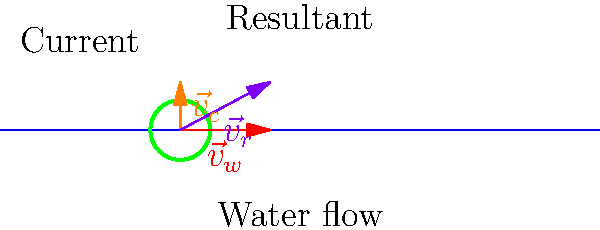A raft is floating down the Li River near Longyan Township. The water is flowing east at 3 m/s, and there's a current pushing the raft north at 1.6 m/s. What is the resultant velocity vector of the raft? To find the resultant velocity vector of the raft, we need to add the two given velocity vectors:

1) Water flow velocity (east): $\vec{v}_w = 3\hat{i}$ m/s
2) Current velocity (north): $\vec{v}_c = 1.6\hat{j}$ m/s

The resultant velocity $\vec{v}_r$ is the vector sum of these two velocities:

$$\vec{v}_r = \vec{v}_w + \vec{v}_c = 3\hat{i} + 1.6\hat{j}$$

To express this as a single vector:

1) The x-component (east) is 3 m/s
2) The y-component (north) is 1.6 m/s

Therefore, the resultant velocity vector is:

$$\vec{v}_r = 3\hat{i} + 1.6\hat{j}$$ m/s

We can also calculate the magnitude and direction of this vector:

Magnitude: $|\vec{v}_r| = \sqrt{3^2 + 1.6^2} = \sqrt{9 + 2.56} = \sqrt{11.56} \approx 3.4$ m/s

Direction: $\theta = \tan^{-1}(\frac{1.6}{3}) \approx 28.1°$ north of east

However, the question asks for the velocity vector, so we'll stick with the component form.
Answer: $\vec{v}_r = 3\hat{i} + 1.6\hat{j}$ m/s 